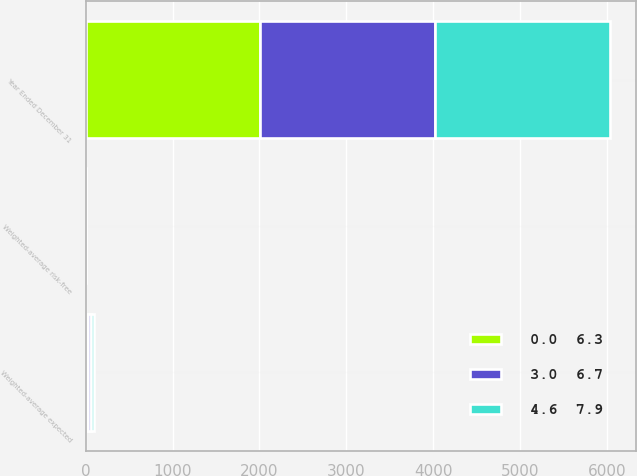Convert chart. <chart><loc_0><loc_0><loc_500><loc_500><stacked_bar_chart><ecel><fcel>Year Ended December 31<fcel>Weighted-average expected<fcel>Weighted-average risk-free<nl><fcel>3.0  6.7<fcel>2013<fcel>28<fcel>2.5<nl><fcel>0.0  6.3<fcel>2012<fcel>31<fcel>1.8<nl><fcel>4.6  7.9<fcel>2011<fcel>36<fcel>2.1<nl></chart> 